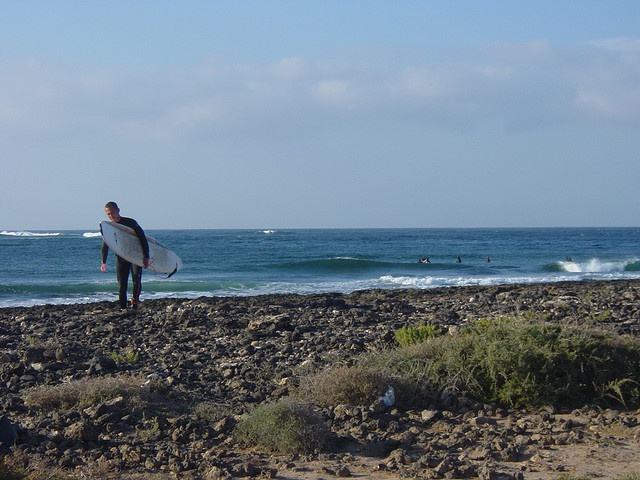Describe the objects in this image and their specific colors. I can see surfboard in lightblue, gray, and blue tones, people in lightblue, black, navy, maroon, and gray tones, people in lightblue, black, blue, and navy tones, people in lightblue, black, blue, gray, and darkblue tones, and people in lightblue, gray, black, navy, and blue tones in this image. 